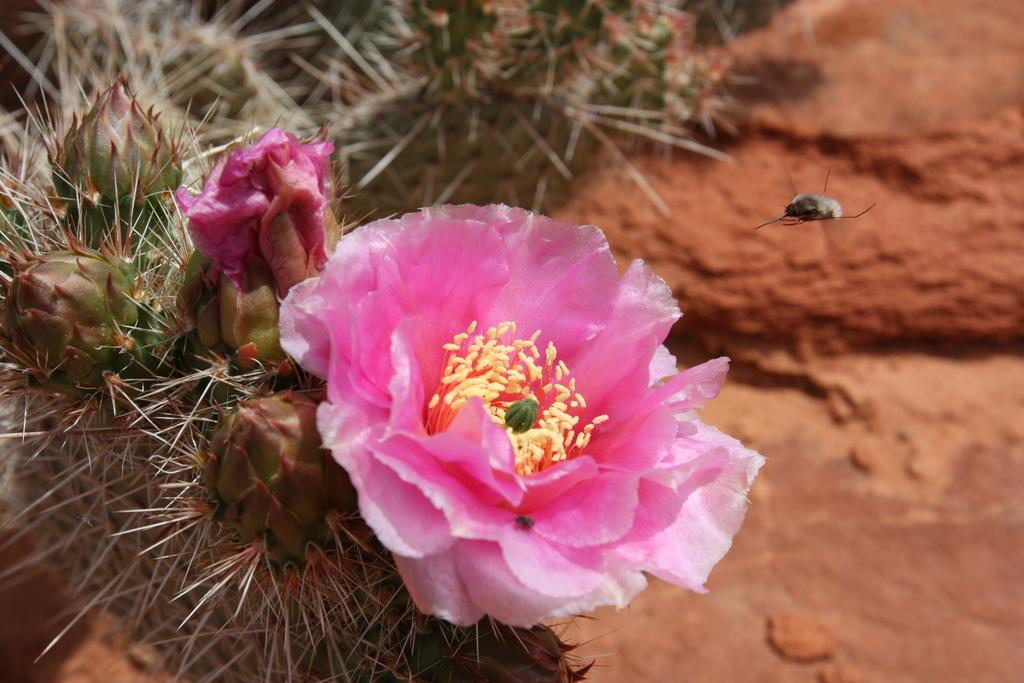What is the main subject of the picture? The main subject of the picture is a flower. Can you describe the colors of the flower? The flower has pink and yellow colors. What else can be seen in the picture besides the flower? There is an insect flying in the air beside the flower. Who is the owner of the bells in the picture? There are no bells present in the image, so it is not possible to determine the owner. 